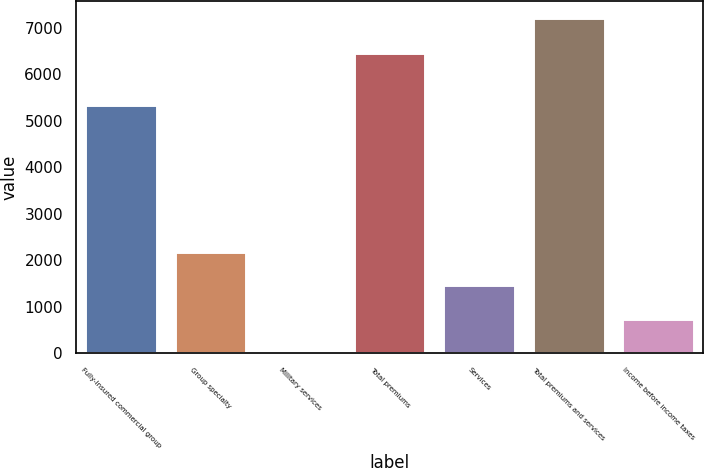Convert chart. <chart><loc_0><loc_0><loc_500><loc_500><bar_chart><fcel>Fully-insured commercial group<fcel>Group specialty<fcel>Military services<fcel>Total premiums<fcel>Services<fcel>Total premiums and services<fcel>Income before income taxes<nl><fcel>5339<fcel>2179<fcel>19<fcel>6456<fcel>1459<fcel>7219<fcel>739<nl></chart> 